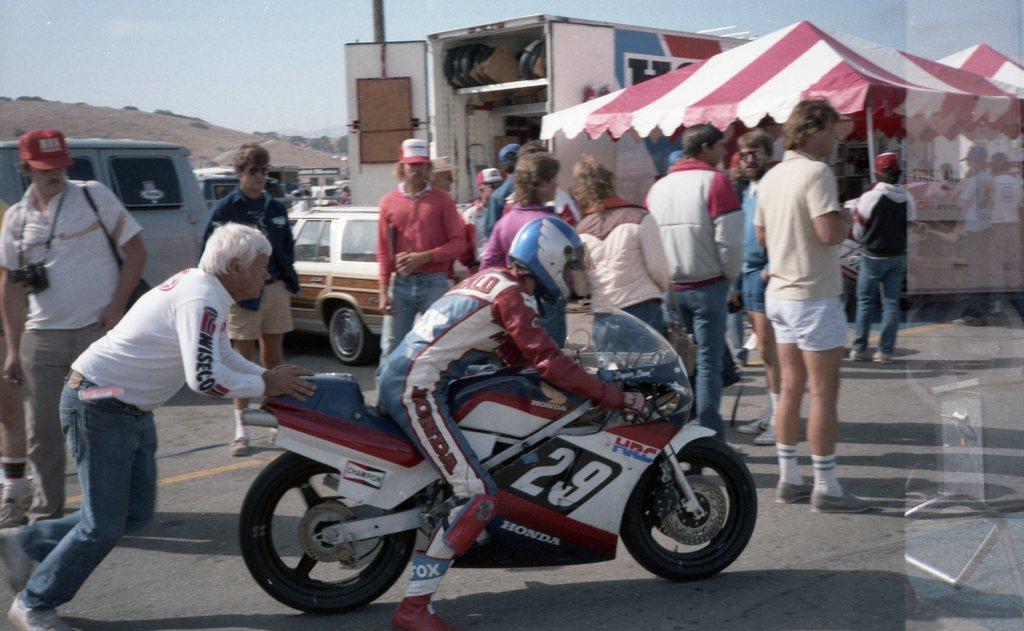How would you summarize this image in a sentence or two? In this image I see a person who is on this bike and I see this man is pushing his bike. In the background I see few more people who are standing on the path and there are vehicles, tents and the sky. 